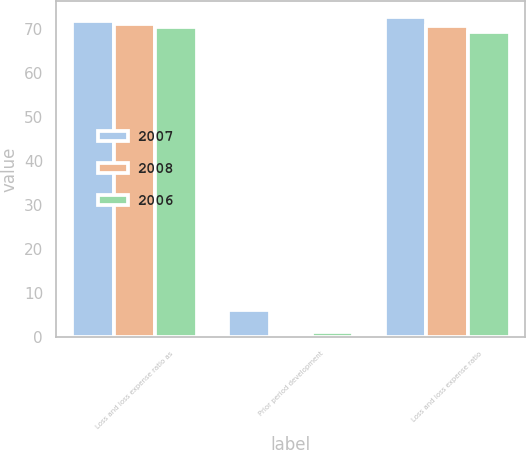Convert chart. <chart><loc_0><loc_0><loc_500><loc_500><stacked_bar_chart><ecel><fcel>Loss and loss expense ratio as<fcel>Prior period development<fcel>Loss and loss expense ratio<nl><fcel>2007<fcel>71.8<fcel>6.2<fcel>72.6<nl><fcel>2008<fcel>71.1<fcel>0.2<fcel>70.6<nl><fcel>2006<fcel>70.4<fcel>1.2<fcel>69.2<nl></chart> 